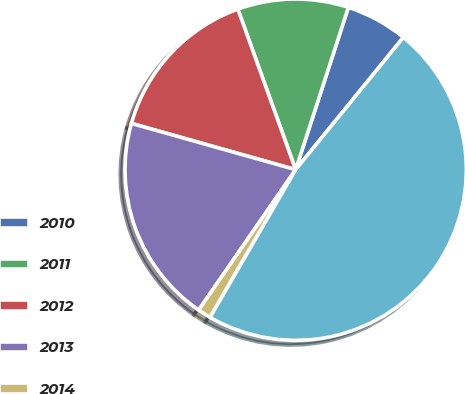Convert chart. <chart><loc_0><loc_0><loc_500><loc_500><pie_chart><fcel>2010<fcel>2011<fcel>2012<fcel>2013<fcel>2014<fcel>Thereafter<nl><fcel>5.88%<fcel>10.5%<fcel>15.13%<fcel>19.75%<fcel>1.26%<fcel>47.49%<nl></chart> 